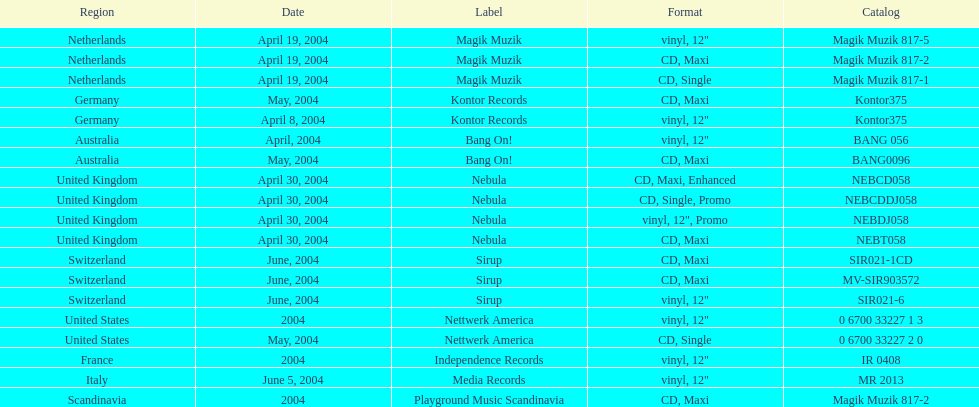What zone is specified at the top? Netherlands. 